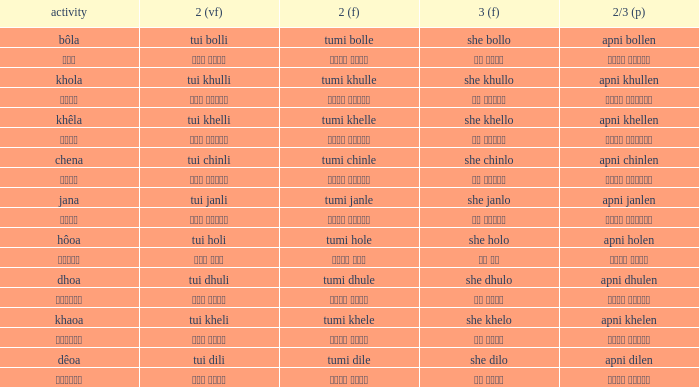What is the 2(vf) for তুমি বললে? তুই বললি. 